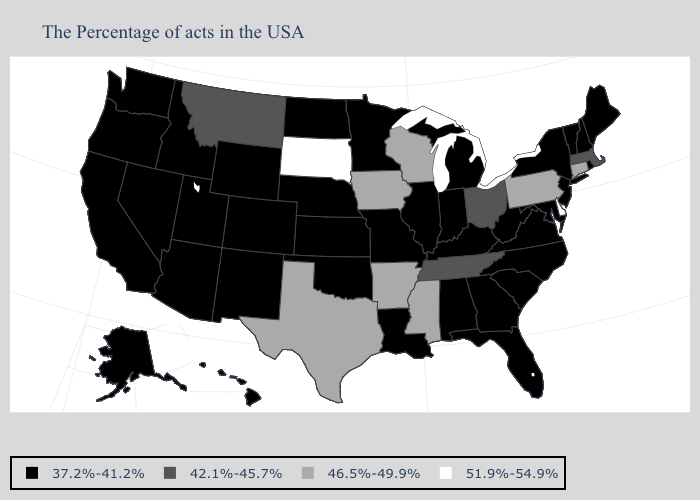What is the value of Alabama?
Quick response, please. 37.2%-41.2%. Does the first symbol in the legend represent the smallest category?
Short answer required. Yes. Name the states that have a value in the range 46.5%-49.9%?
Short answer required. Connecticut, Pennsylvania, Wisconsin, Mississippi, Arkansas, Iowa, Texas. What is the value of West Virginia?
Short answer required. 37.2%-41.2%. Does Massachusetts have a higher value than Maine?
Keep it brief. Yes. What is the value of Illinois?
Write a very short answer. 37.2%-41.2%. Name the states that have a value in the range 42.1%-45.7%?
Be succinct. Massachusetts, Ohio, Tennessee, Montana. What is the value of New Hampshire?
Keep it brief. 37.2%-41.2%. Among the states that border Colorado , which have the highest value?
Be succinct. Kansas, Nebraska, Oklahoma, Wyoming, New Mexico, Utah, Arizona. Which states have the lowest value in the West?
Answer briefly. Wyoming, Colorado, New Mexico, Utah, Arizona, Idaho, Nevada, California, Washington, Oregon, Alaska, Hawaii. Name the states that have a value in the range 42.1%-45.7%?
Quick response, please. Massachusetts, Ohio, Tennessee, Montana. Among the states that border Pennsylvania , which have the lowest value?
Answer briefly. New York, New Jersey, Maryland, West Virginia. Name the states that have a value in the range 46.5%-49.9%?
Answer briefly. Connecticut, Pennsylvania, Wisconsin, Mississippi, Arkansas, Iowa, Texas. What is the value of Nebraska?
Short answer required. 37.2%-41.2%. 